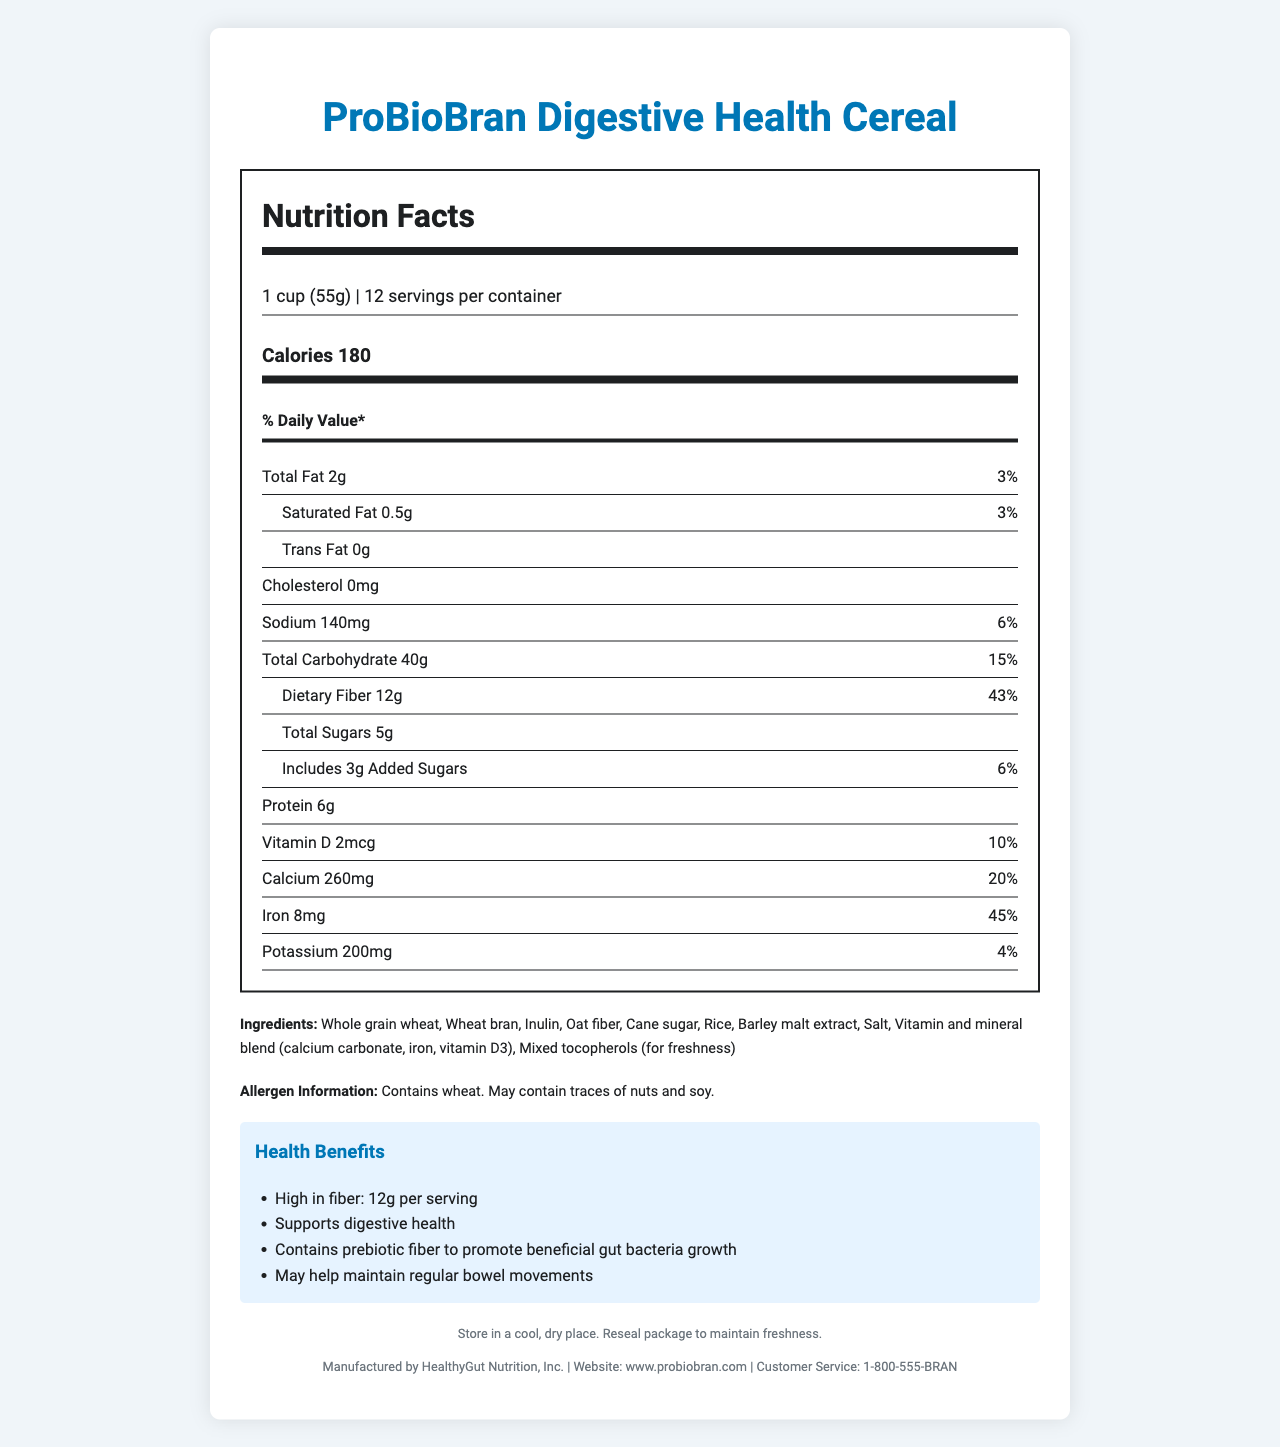What is the serving size of the ProBioBran Digestive Health Cereal? The serving size is specified at the top of the nutrition label as "1 cup (55g)".
Answer: 1 cup (55g) How many calories are in a serving of this cereal? The calorie information is listed clearly near the top of the nutrition label under "Calories 180".
Answer: 180 What percentage of the daily value for dietary fiber does one serving of this cereal provide? The amount of dietary fiber is noted to be 12g, which is 43% of the daily value.
Answer: 43% How much protein is in each serving of this cereal? The protein content is listed as "Protein 6g" on the nutrition label.
Answer: 6g What is the total amount of sugar, including added sugars, in one serving? The nutrition label shows "Total Sugars 5g" and "Includes 3g Added Sugars", which together sum up to 5g of sugar.
Answer: 5g Which of the following is NOT an ingredient in the ProBioBran Digestive Health Cereal? A. Whole grain wheat B. Oat fiber C. Corn syrup D. Mixed tocopherols The ingredients list includes whole grain wheat, oat fiber, and mixed tocopherols but does not include corn syrup.
Answer: C How much iron is in one serving of this cereal? A. 8mg B. 260mg C. 2mcg D. 200mg The iron content is listed as "Iron 8mg (45% Daily Value)" on the nutrition label.
Answer: A Does this cereal contain any cholesterol? The label specifies "Cholesterol 0mg", indicating the cereal contains no cholesterol.
Answer: No Does the cereal contain any prebiotic fiber? The health claims section states that the cereal contains prebiotic fiber to promote beneficial gut bacteria growth.
Answer: Yes Summarize the main benefits of the ProBioBran Digestive Health Cereal as outlined in the document. The document highlights the cereal's high fiber content and its specific prebiotic ingredients like inulin and oat fiber, which support beneficial gut bacteria. Additionally, it explains the potential digestive health benefits and regular bowel movements.
Answer: The ProBioBran Digestive Health Cereal is a high-fiber cereal designed to support digestive health. It contains 12g of dietary fiber per serving, including prebiotics like inulin and oat fiber that promote the growth of beneficial gut bacteria. This can help mitigate the negative effects of antibiotics on gut microbiota and maintain regular bowel movements. Does the nutrition label say how much vitamin C is in the cereal? The nutrition label does not mention vitamin C content at all.
Answer: Not enough information 